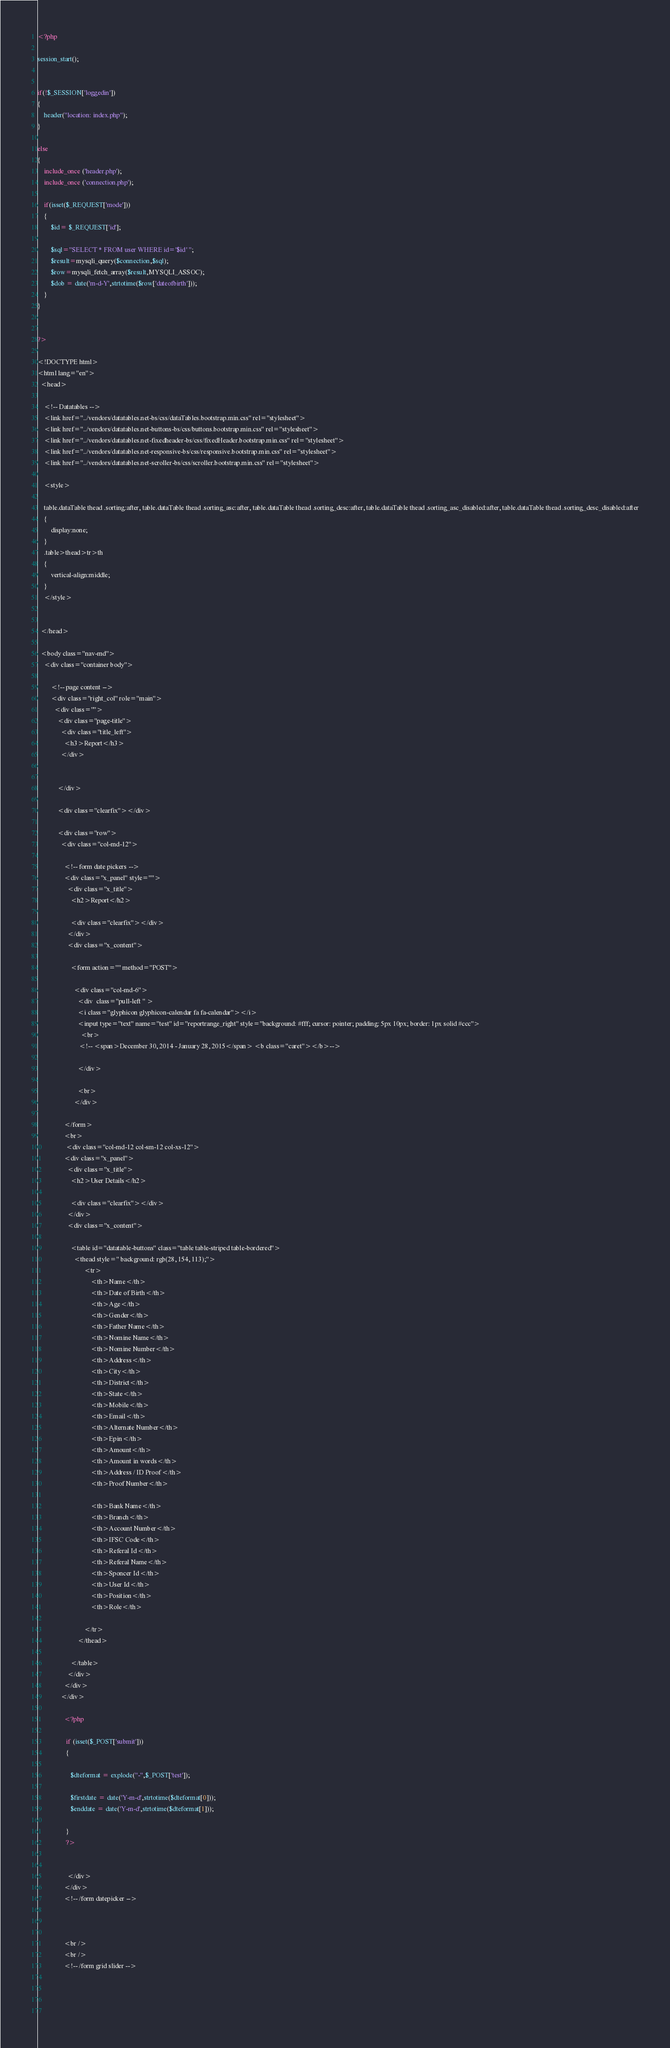Convert code to text. <code><loc_0><loc_0><loc_500><loc_500><_PHP_><?php

session_start();


if(!$_SESSION['loggedin'])
{
	header("location: index.php"); 
}

else
{
	include_once ('header.php');
	include_once ('connection.php');
	
	if(isset($_REQUEST['mode'])) 
	{
		$id= $_REQUEST['id'];
		
		$sql="SELECT * FROM user WHERE id='$id' ";
		$result=mysqli_query($connection,$sql);
		$row=mysqli_fetch_array($result,MYSQLI_ASSOC);	
		$dob = date('m-d-Y',strtotime($row['dateofbirth'])); 
	}
}

	
?>

<!DOCTYPE html>
<html lang="en">
  <head>
    
	<!-- Datatables -->
    <link href="../vendors/datatables.net-bs/css/dataTables.bootstrap.min.css" rel="stylesheet">
    <link href="../vendors/datatables.net-buttons-bs/css/buttons.bootstrap.min.css" rel="stylesheet">
    <link href="../vendors/datatables.net-fixedheader-bs/css/fixedHeader.bootstrap.min.css" rel="stylesheet">
    <link href="../vendors/datatables.net-responsive-bs/css/responsive.bootstrap.min.css" rel="stylesheet">
    <link href="../vendors/datatables.net-scroller-bs/css/scroller.bootstrap.min.css" rel="stylesheet">
	
	<style>
	
	table.dataTable thead .sorting:after, table.dataTable thead .sorting_asc:after, table.dataTable thead .sorting_desc:after, table.dataTable thead .sorting_asc_disabled:after, table.dataTable thead .sorting_desc_disabled:after
	{
		display:none;
	}
	.table>thead>tr>th
	{
		vertical-align:middle;
	}
	</style>
	
	
  </head>

  <body class="nav-md">
    <div class="container body">
      
        <!-- page content -->
        <div class="right_col" role="main">
          <div class="">
            <div class="page-title">
              <div class="title_left">
                <h3>Report</h3>
              </div>

            
            </div>

            <div class="clearfix"></div>

            <div class="row">
              <div class="col-md-12">

                <!-- form date pickers -->
                <div class="x_panel" style="">
                  <div class="x_title">
                    <h2>Report</h2>
                   
                    <div class="clearfix"></div>
                  </div>
                  <div class="x_content">

					<form action="" method="POST">
                    
                      <div class="col-md-6">
                        <div  class="pull-left " >
						<i class="glyphicon glyphicon-calendar fa fa-calendar"></i>
						<input type="text" name="test" id="reportrange_right" style="background: #fff; cursor: pointer; padding: 5px 10px; border: 1px solid #ccc">
                          <br>
                         <!-- <span>December 30, 2014 - January 28, 2015</span> <b class="caret"></b>-->
						  
                        </div>
						
						<br>
					  </div>

				</form>
				<br>
				 <div class="col-md-12 col-sm-12 col-xs-12">
                <div class="x_panel">
                  <div class="x_title">
                    <h2>User Details</h2>
                   
                    <div class="clearfix"></div>
                  </div>
                  <div class="x_content">
                    
                    <table id="datatable-buttons" class="table table-striped table-bordered">
                      <thead style=" background: rgb(28, 154, 113);">
							<tr>
								<th>Name</th>
								<th>Date of Birth</th>
								<th>Age</th>
								<th>Gender</th>
								<th>Father Name</th>
								<th>Nomine Name</th>
								<th>Nomine Number</th>
								<th>Address</th>
								<th>City</th>
								<th>District</th>
								<th>State</th>
								<th>Mobile</th>
								<th>Email</th>
								<th>Alternate Number</th>
								<th>Epin</th>
								<th>Amount</th>
								<th>Amount in words</th>
								<th>Address / ID Proof</th>
								<th>Proof Number</th>
								
								<th>Bank Name</th>
								<th>Branch</th>								
								<th>Account Number</th>
								<th>IFSC Code</th>
								<th>Referal Id</th>
								<th>Referal Name</th>
								<th>Sponcer Id</th>
								<th>User Id</th>
								<th>Position</th>
								<th>Role</th>
							   
							</tr>
						</thead>
                        
                    </table>
                  </div>
                </div>
              </div>
				
				<?php 
						
				 if (isset($_POST['submit'])) 
				 {
					
					$dteformat = explode("-",$_POST['test']);
					
					$firstdate = date('Y-m-d',strtotime($dteformat[0]));
					$enddate = date('Y-m-d',strtotime($dteformat[1])); 					

				 }
				 ?>
					

                  </div>
                </div>
                <!-- /form datepicker -->


               
                <br />
                <br />
                <!-- /form grid slider -->

             
				
				</code> 